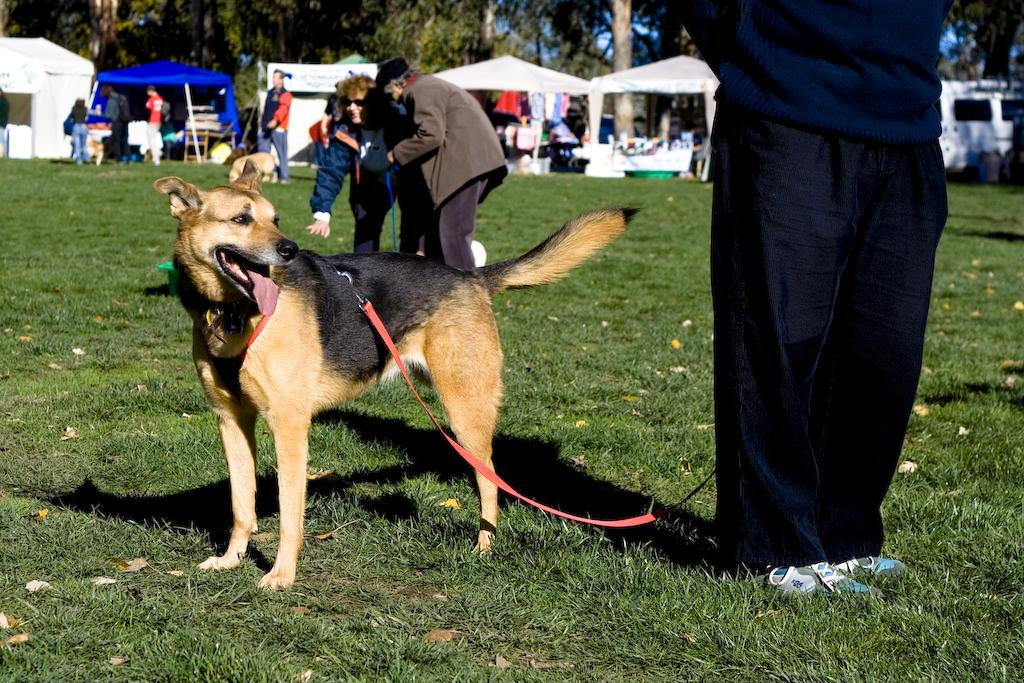What can be seen on the ground in the image? There are people on the ground in the image. What animals are present in the image? There are dogs in the image. What structures can be seen in the background of the image? There are tents in the background of the image. What type of vegetation is visible in the background of the image? There are trees in the background of the image. What color is the son's shirt in the image? There is no mention of a son or a shirt in the image, so we cannot answer this question. 